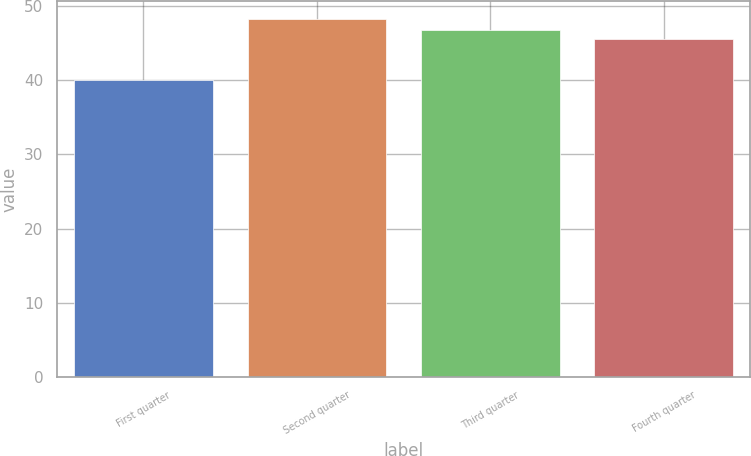<chart> <loc_0><loc_0><loc_500><loc_500><bar_chart><fcel>First quarter<fcel>Second quarter<fcel>Third quarter<fcel>Fourth quarter<nl><fcel>39.99<fcel>48.22<fcel>46.73<fcel>45.55<nl></chart> 